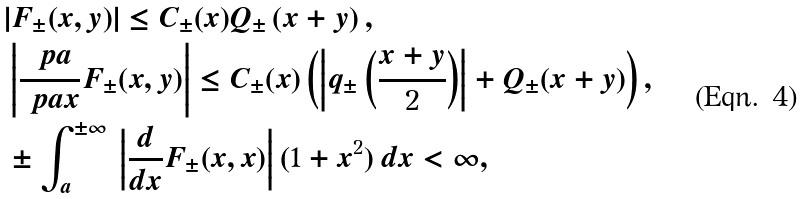Convert formula to latex. <formula><loc_0><loc_0><loc_500><loc_500>& | F _ { \pm } ( x , y ) | \leq C _ { \pm } ( x ) Q _ { \pm } \left ( x + y \right ) , \\ & \left | \frac { \ p a } { \ p a x } F _ { \pm } ( x , y ) \right | \leq C _ { \pm } ( x ) \left ( \left | q _ { \pm } \left ( \frac { x + y } { 2 } \right ) \right | + Q _ { \pm } ( x + y ) \right ) , \\ & \pm \int _ { a } ^ { \pm \infty } \, \left | \frac { d } { d x } F _ { \pm } ( x , x ) \right | ( 1 + x ^ { 2 } ) \, d x < \infty ,</formula> 